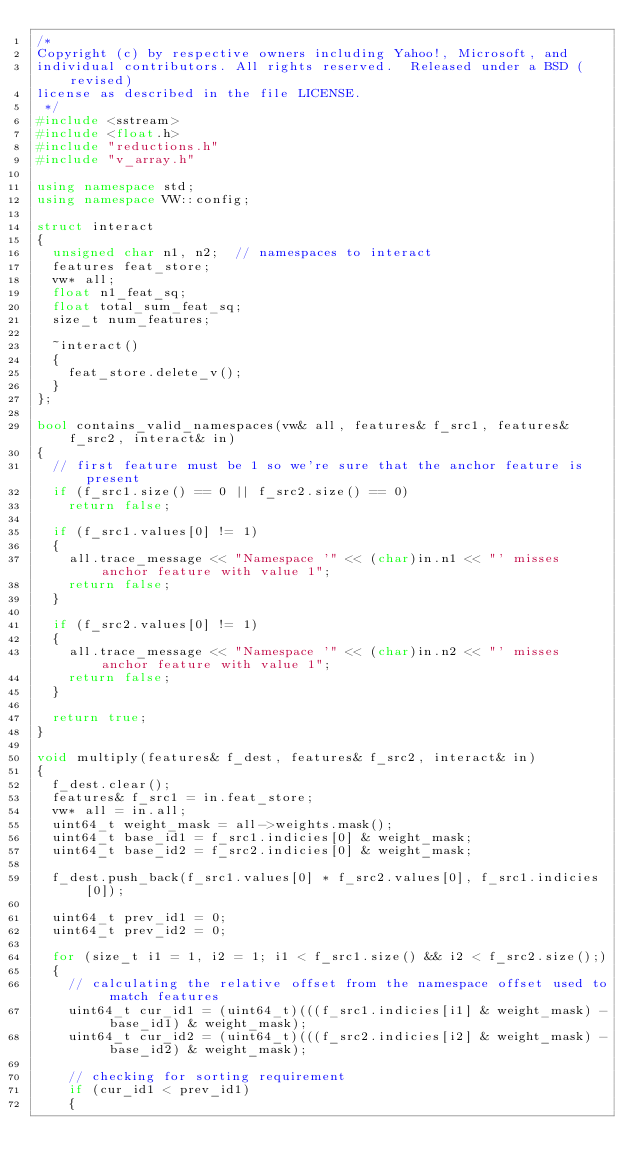<code> <loc_0><loc_0><loc_500><loc_500><_C++_>/*
Copyright (c) by respective owners including Yahoo!, Microsoft, and
individual contributors. All rights reserved.  Released under a BSD (revised)
license as described in the file LICENSE.
 */
#include <sstream>
#include <float.h>
#include "reductions.h"
#include "v_array.h"

using namespace std;
using namespace VW::config;

struct interact
{
  unsigned char n1, n2;  // namespaces to interact
  features feat_store;
  vw* all;
  float n1_feat_sq;
  float total_sum_feat_sq;
  size_t num_features;

  ~interact()
  {
    feat_store.delete_v();
  }
};

bool contains_valid_namespaces(vw& all, features& f_src1, features& f_src2, interact& in)
{
  // first feature must be 1 so we're sure that the anchor feature is present
  if (f_src1.size() == 0 || f_src2.size() == 0)
    return false;

  if (f_src1.values[0] != 1)
  {
    all.trace_message << "Namespace '" << (char)in.n1 << "' misses anchor feature with value 1";
    return false;
  }

  if (f_src2.values[0] != 1)
  {
    all.trace_message << "Namespace '" << (char)in.n2 << "' misses anchor feature with value 1";
    return false;
  }

  return true;
}

void multiply(features& f_dest, features& f_src2, interact& in)
{
  f_dest.clear();
  features& f_src1 = in.feat_store;
  vw* all = in.all;
  uint64_t weight_mask = all->weights.mask();
  uint64_t base_id1 = f_src1.indicies[0] & weight_mask;
  uint64_t base_id2 = f_src2.indicies[0] & weight_mask;

  f_dest.push_back(f_src1.values[0] * f_src2.values[0], f_src1.indicies[0]);

  uint64_t prev_id1 = 0;
  uint64_t prev_id2 = 0;

  for (size_t i1 = 1, i2 = 1; i1 < f_src1.size() && i2 < f_src2.size();)
  {
    // calculating the relative offset from the namespace offset used to match features
    uint64_t cur_id1 = (uint64_t)(((f_src1.indicies[i1] & weight_mask) - base_id1) & weight_mask);
    uint64_t cur_id2 = (uint64_t)(((f_src2.indicies[i2] & weight_mask) - base_id2) & weight_mask);

    // checking for sorting requirement
    if (cur_id1 < prev_id1)
    {</code> 